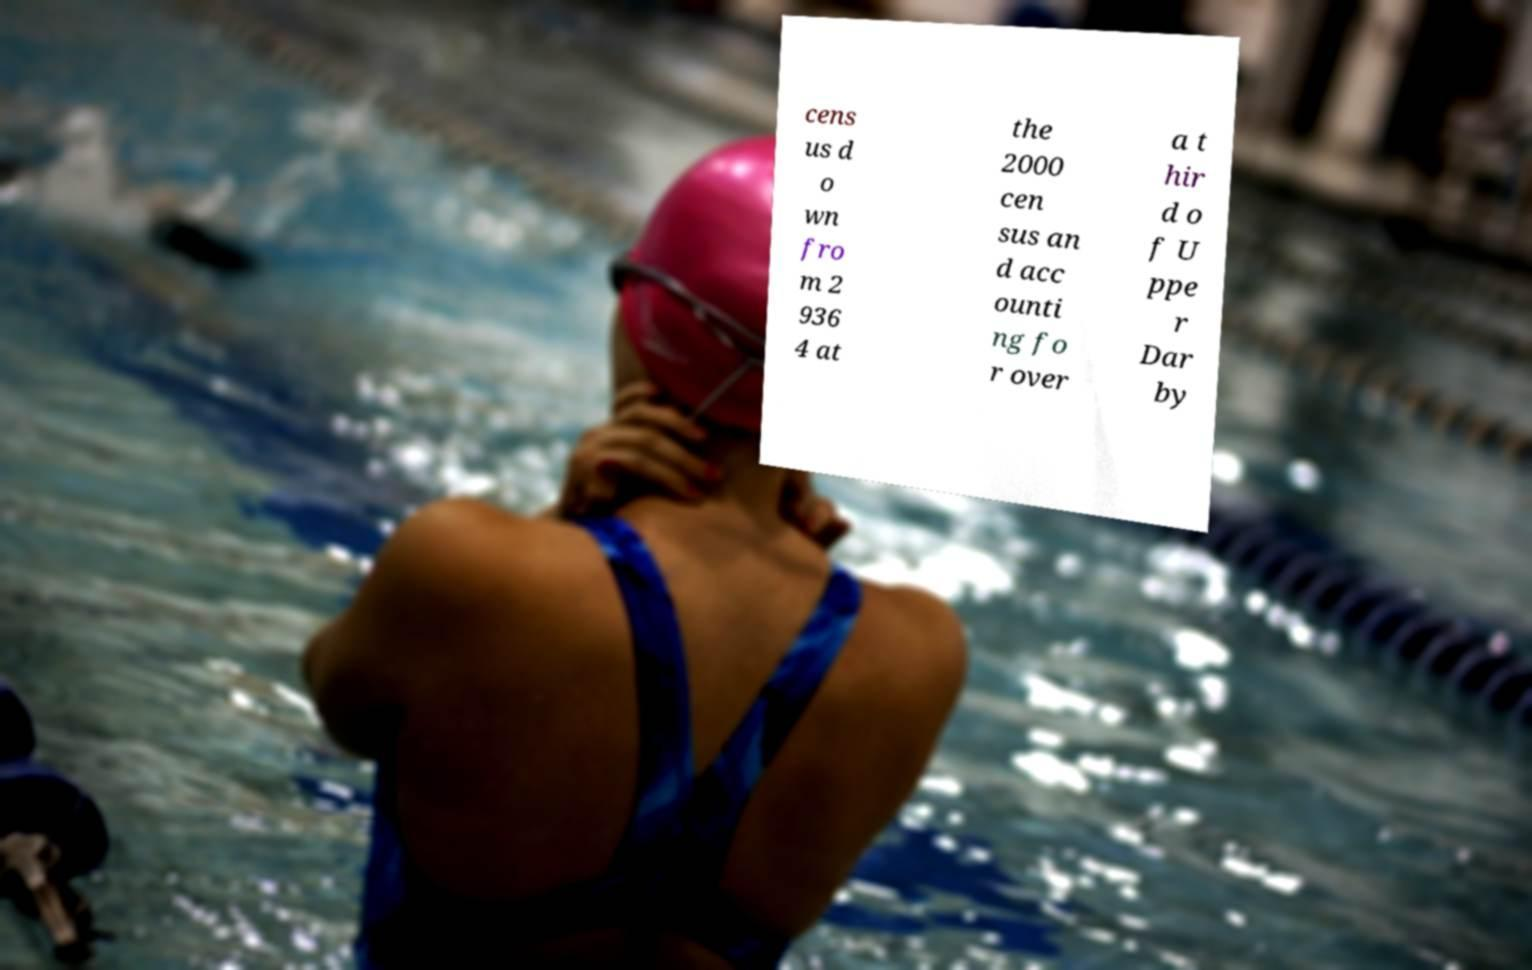Could you assist in decoding the text presented in this image and type it out clearly? cens us d o wn fro m 2 936 4 at the 2000 cen sus an d acc ounti ng fo r over a t hir d o f U ppe r Dar by 